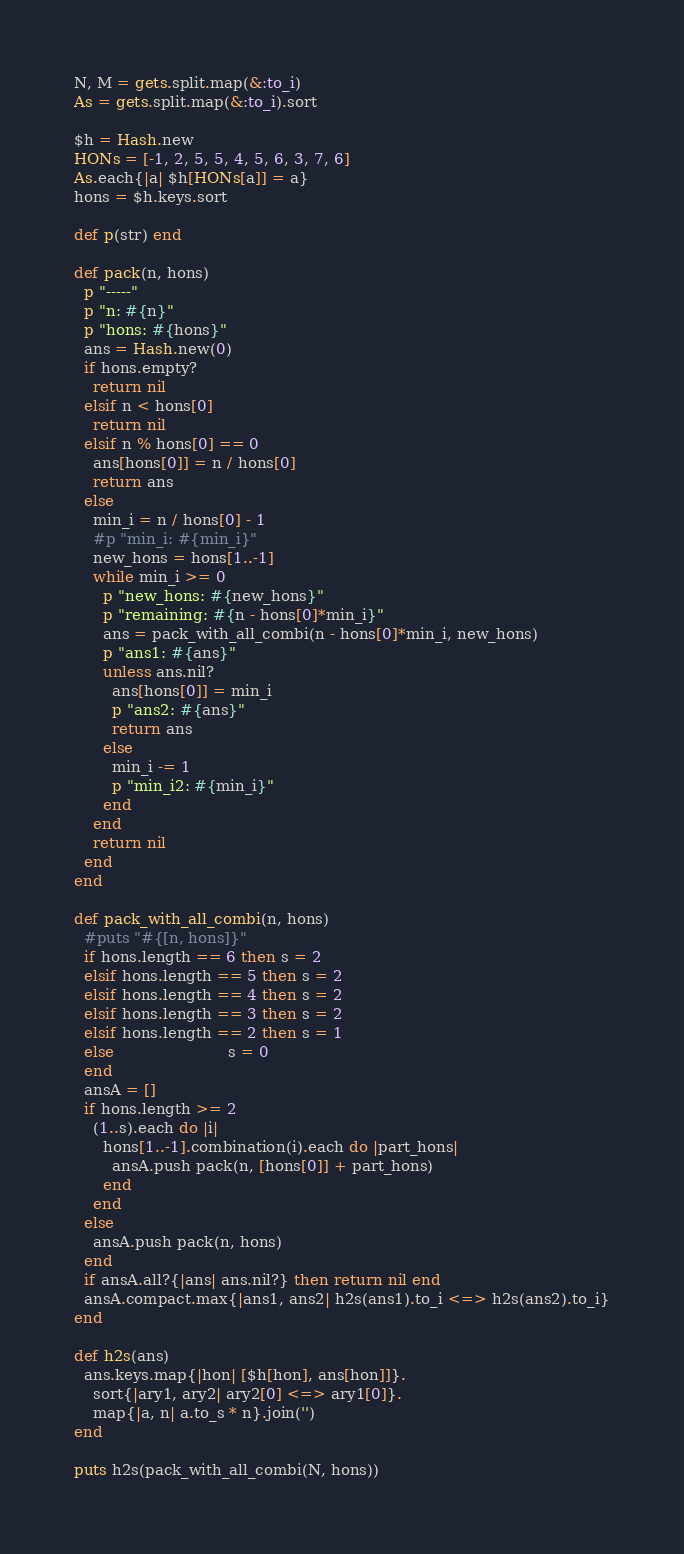Convert code to text. <code><loc_0><loc_0><loc_500><loc_500><_Ruby_>N, M = gets.split.map(&:to_i)
As = gets.split.map(&:to_i).sort

$h = Hash.new
HONs = [-1, 2, 5, 5, 4, 5, 6, 3, 7, 6]
As.each{|a| $h[HONs[a]] = a}
hons = $h.keys.sort

def p(str) end

def pack(n, hons)
  p "-----"
  p "n: #{n}"
  p "hons: #{hons}"
  ans = Hash.new(0)
  if hons.empty?
    return nil
  elsif n < hons[0]
    return nil
  elsif n % hons[0] == 0
    ans[hons[0]] = n / hons[0]
    return ans
  else
    min_i = n / hons[0] - 1
    #p "min_i: #{min_i}"
    new_hons = hons[1..-1]
    while min_i >= 0
      p "new_hons: #{new_hons}"
      p "remaining: #{n - hons[0]*min_i}"
      ans = pack_with_all_combi(n - hons[0]*min_i, new_hons)
      p "ans1: #{ans}"
      unless ans.nil?
        ans[hons[0]] = min_i
        p "ans2: #{ans}"
        return ans
      else
        min_i -= 1
        p "min_i2: #{min_i}"
      end
    end
    return nil
  end
end

def pack_with_all_combi(n, hons)
  #puts "#{[n, hons]}"
  if hons.length == 6 then s = 2
  elsif hons.length == 5 then s = 2
  elsif hons.length == 4 then s = 2
  elsif hons.length == 3 then s = 2
  elsif hons.length == 2 then s = 1
  else                        s = 0
  end
  ansA = []
  if hons.length >= 2
    (1..s).each do |i|
      hons[1..-1].combination(i).each do |part_hons|
        ansA.push pack(n, [hons[0]] + part_hons)
      end
    end
  else
    ansA.push pack(n, hons)
  end
  if ansA.all?{|ans| ans.nil?} then return nil end
  ansA.compact.max{|ans1, ans2| h2s(ans1).to_i <=> h2s(ans2).to_i}
end

def h2s(ans)
  ans.keys.map{|hon| [$h[hon], ans[hon]]}.
    sort{|ary1, ary2| ary2[0] <=> ary1[0]}.
    map{|a, n| a.to_s * n}.join('')
end

puts h2s(pack_with_all_combi(N, hons))</code> 